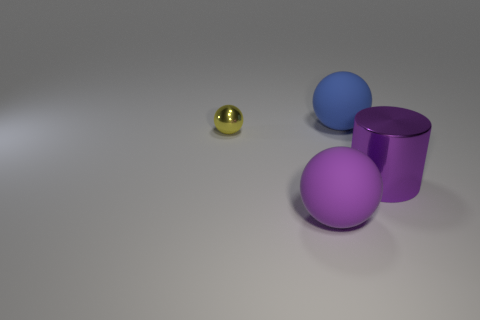There is a metal object left of the big rubber object that is behind the tiny ball; what is its size?
Keep it short and to the point. Small. Is there any other thing that is the same size as the blue sphere?
Your answer should be very brief. Yes. What material is the other purple object that is the same shape as the tiny metal thing?
Provide a short and direct response. Rubber. Does the shiny thing that is on the right side of the big purple rubber sphere have the same shape as the large rubber thing that is behind the yellow thing?
Ensure brevity in your answer.  No. Is the number of large blue balls greater than the number of big blue rubber cubes?
Provide a short and direct response. Yes. The cylinder has what size?
Your answer should be very brief. Large. What number of other things are the same color as the metallic cylinder?
Your response must be concise. 1. Do the large ball that is in front of the large metallic thing and the small yellow object have the same material?
Keep it short and to the point. No. Are there fewer yellow balls that are in front of the large purple metal thing than metallic cylinders in front of the big purple rubber ball?
Offer a very short reply. No. How many other things are there of the same material as the purple sphere?
Provide a short and direct response. 1. 